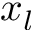Convert formula to latex. <formula><loc_0><loc_0><loc_500><loc_500>x _ { l }</formula> 